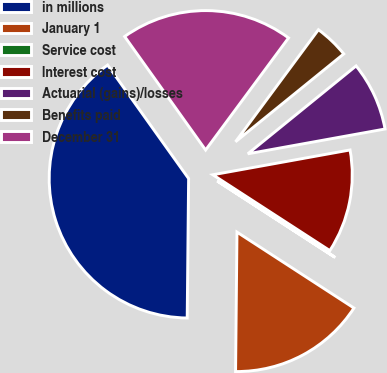Convert chart to OTSL. <chart><loc_0><loc_0><loc_500><loc_500><pie_chart><fcel>in millions<fcel>January 1<fcel>Service cost<fcel>Interest cost<fcel>Actuarial (gains)/losses<fcel>Benefits paid<fcel>December 31<nl><fcel>39.98%<fcel>16.0%<fcel>0.01%<fcel>12.0%<fcel>8.01%<fcel>4.01%<fcel>20.0%<nl></chart> 